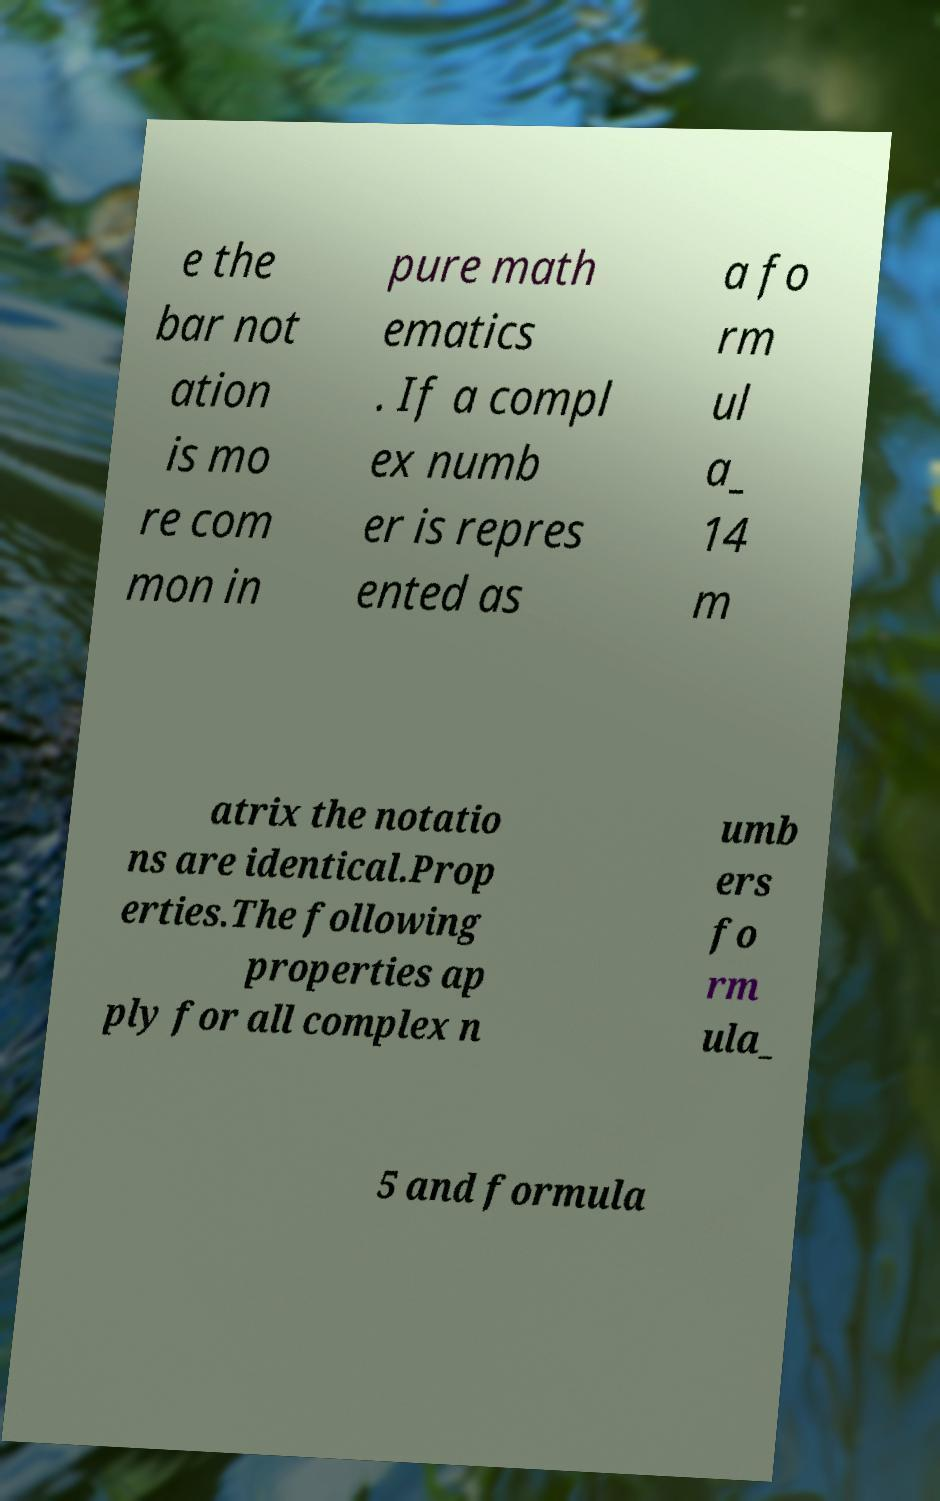What messages or text are displayed in this image? I need them in a readable, typed format. e the bar not ation is mo re com mon in pure math ematics . If a compl ex numb er is repres ented as a fo rm ul a_ 14 m atrix the notatio ns are identical.Prop erties.The following properties ap ply for all complex n umb ers fo rm ula_ 5 and formula 